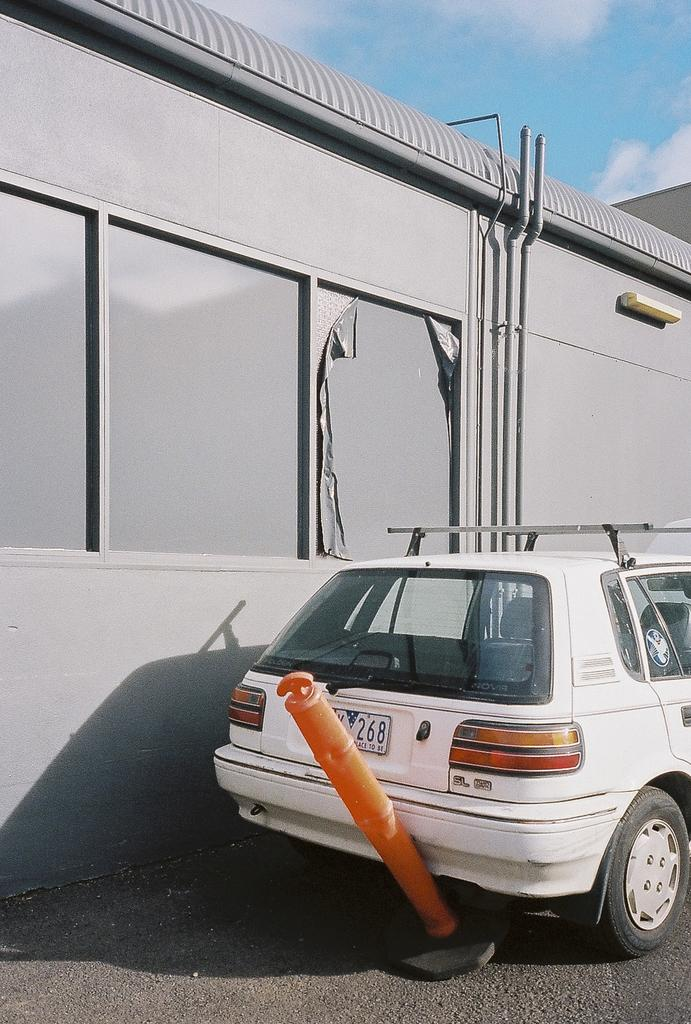What is the main subject of the image? There is a vehicle in the image. What is located on the road in the image? There is an object on the road in the image. What can be seen in the background of the image? There is a wall, pipes, and other objects in the background of the image. What is visible at the top of the image? The sky is visible at the top of the image. What can be observed in the sky? Clouds are present in the sky. How many ducks are swimming in the sand in the image? There are no ducks or sand present in the image. 